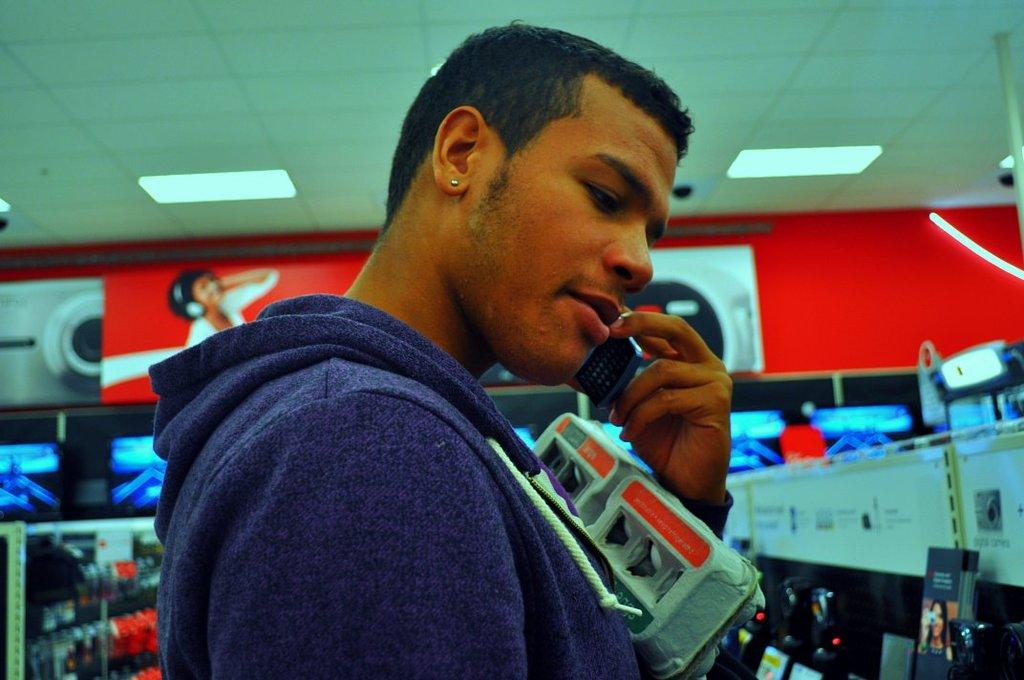What is the main subject of the image? There is a man standing in the image. What is the man doing in the image? The man is holding some objects. What can be seen in the background of the image? There are lights on the ceiling and other objects visible in the background of the image. What color is the tramp in the image? There is no tramp present in the image. What action is the man performing in the image? The provided facts do not specify the action the man is performing, only that he is holding some objects. 